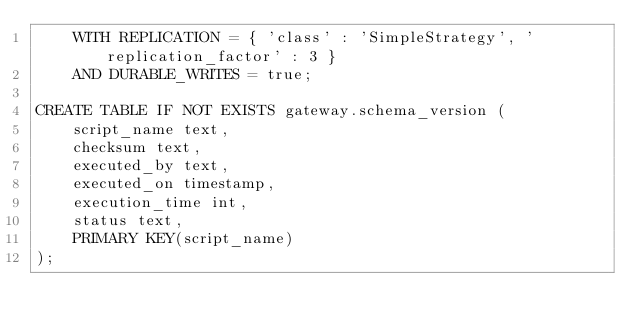<code> <loc_0><loc_0><loc_500><loc_500><_SQL_>    WITH REPLICATION = { 'class' : 'SimpleStrategy', 'replication_factor' : 3 }
    AND DURABLE_WRITES = true;

CREATE TABLE IF NOT EXISTS gateway.schema_version (
    script_name text,
    checksum text,
    executed_by text,
    executed_on timestamp,
    execution_time int,
    status text,
    PRIMARY KEY(script_name)
);
</code> 